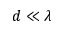<formula> <loc_0><loc_0><loc_500><loc_500>d \ll \lambda</formula> 